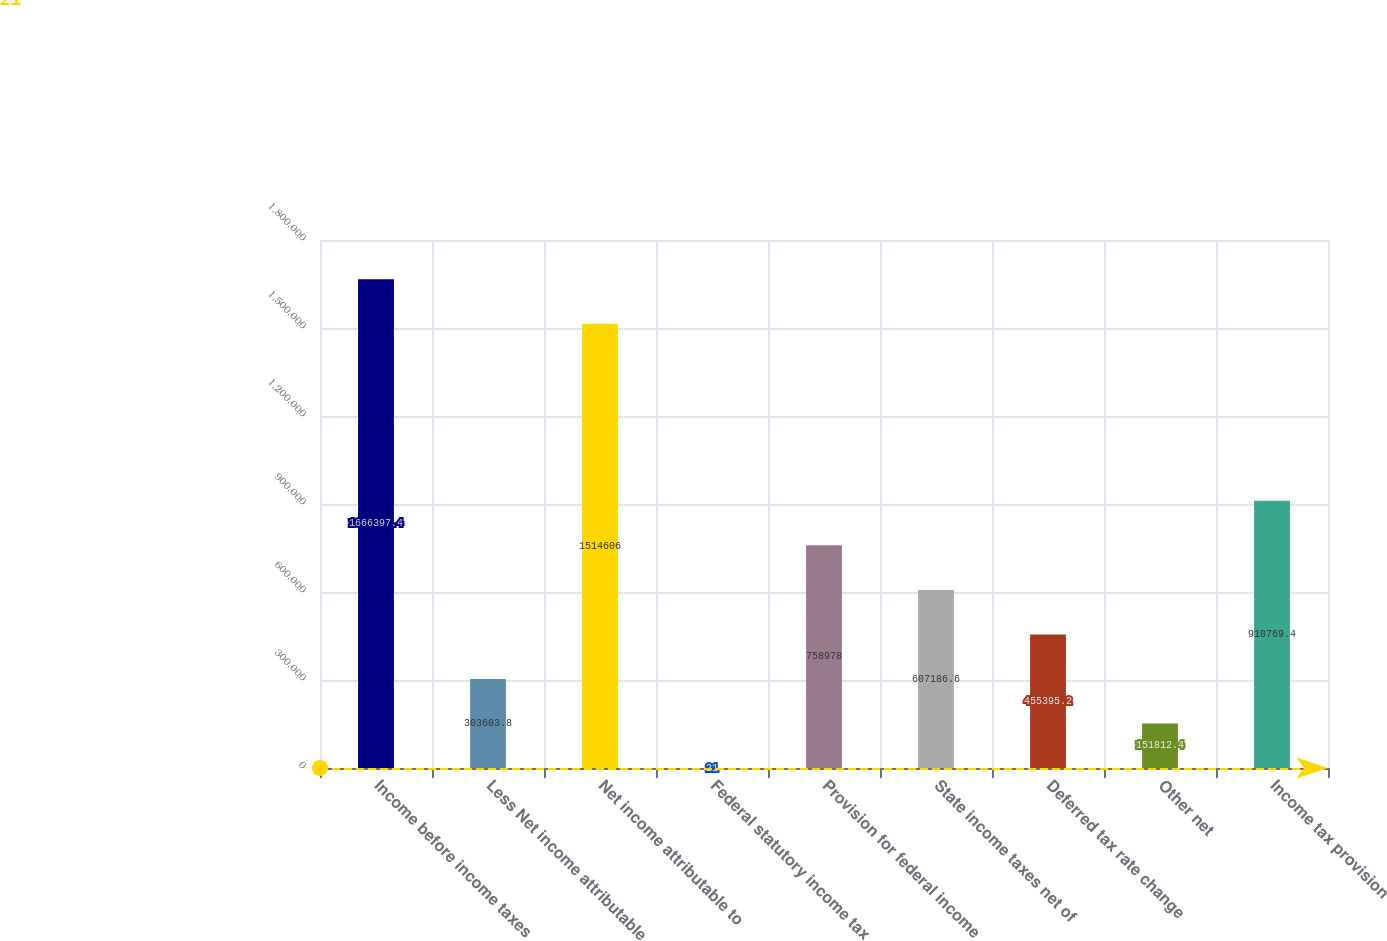<chart> <loc_0><loc_0><loc_500><loc_500><bar_chart><fcel>Income before income taxes<fcel>Less Net income attributable<fcel>Net income attributable to<fcel>Federal statutory income tax<fcel>Provision for federal income<fcel>State income taxes net of<fcel>Deferred tax rate change<fcel>Other net<fcel>Income tax provision<nl><fcel>1.6664e+06<fcel>303604<fcel>1.51461e+06<fcel>21<fcel>758978<fcel>607187<fcel>455395<fcel>151812<fcel>910769<nl></chart> 